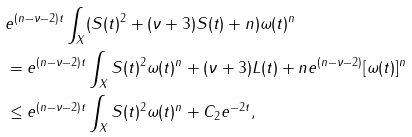Convert formula to latex. <formula><loc_0><loc_0><loc_500><loc_500>& e ^ { ( n - \nu - 2 ) t } \int _ { X } ( S ( t ) ^ { 2 } + ( \nu + 3 ) S ( t ) + n ) \omega ( t ) ^ { n } \\ & = e ^ { ( n - \nu - 2 ) t } \int _ { X } S ( t ) ^ { 2 } \omega ( t ) ^ { n } + ( \nu + 3 ) L ( t ) + n e ^ { ( n - \nu - 2 ) } [ \omega ( t ) ] ^ { n } \\ & \leq e ^ { ( n - \nu - 2 ) t } \int _ { X } S ( t ) ^ { 2 } \omega ( t ) ^ { n } + C _ { 2 } e ^ { - 2 t } ,</formula> 